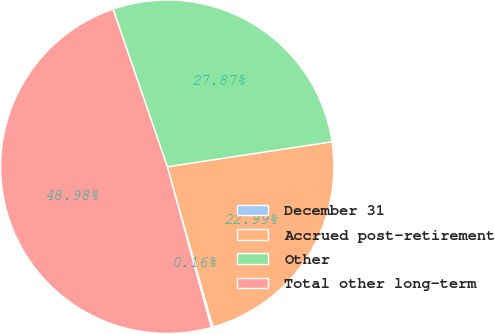Convert chart to OTSL. <chart><loc_0><loc_0><loc_500><loc_500><pie_chart><fcel>December 31<fcel>Accrued post-retirement<fcel>Other<fcel>Total other long-term<nl><fcel>0.16%<fcel>22.99%<fcel>27.87%<fcel>48.98%<nl></chart> 